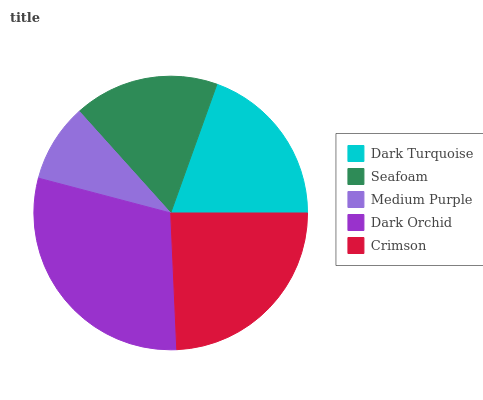Is Medium Purple the minimum?
Answer yes or no. Yes. Is Dark Orchid the maximum?
Answer yes or no. Yes. Is Seafoam the minimum?
Answer yes or no. No. Is Seafoam the maximum?
Answer yes or no. No. Is Dark Turquoise greater than Seafoam?
Answer yes or no. Yes. Is Seafoam less than Dark Turquoise?
Answer yes or no. Yes. Is Seafoam greater than Dark Turquoise?
Answer yes or no. No. Is Dark Turquoise less than Seafoam?
Answer yes or no. No. Is Dark Turquoise the high median?
Answer yes or no. Yes. Is Dark Turquoise the low median?
Answer yes or no. Yes. Is Dark Orchid the high median?
Answer yes or no. No. Is Dark Orchid the low median?
Answer yes or no. No. 